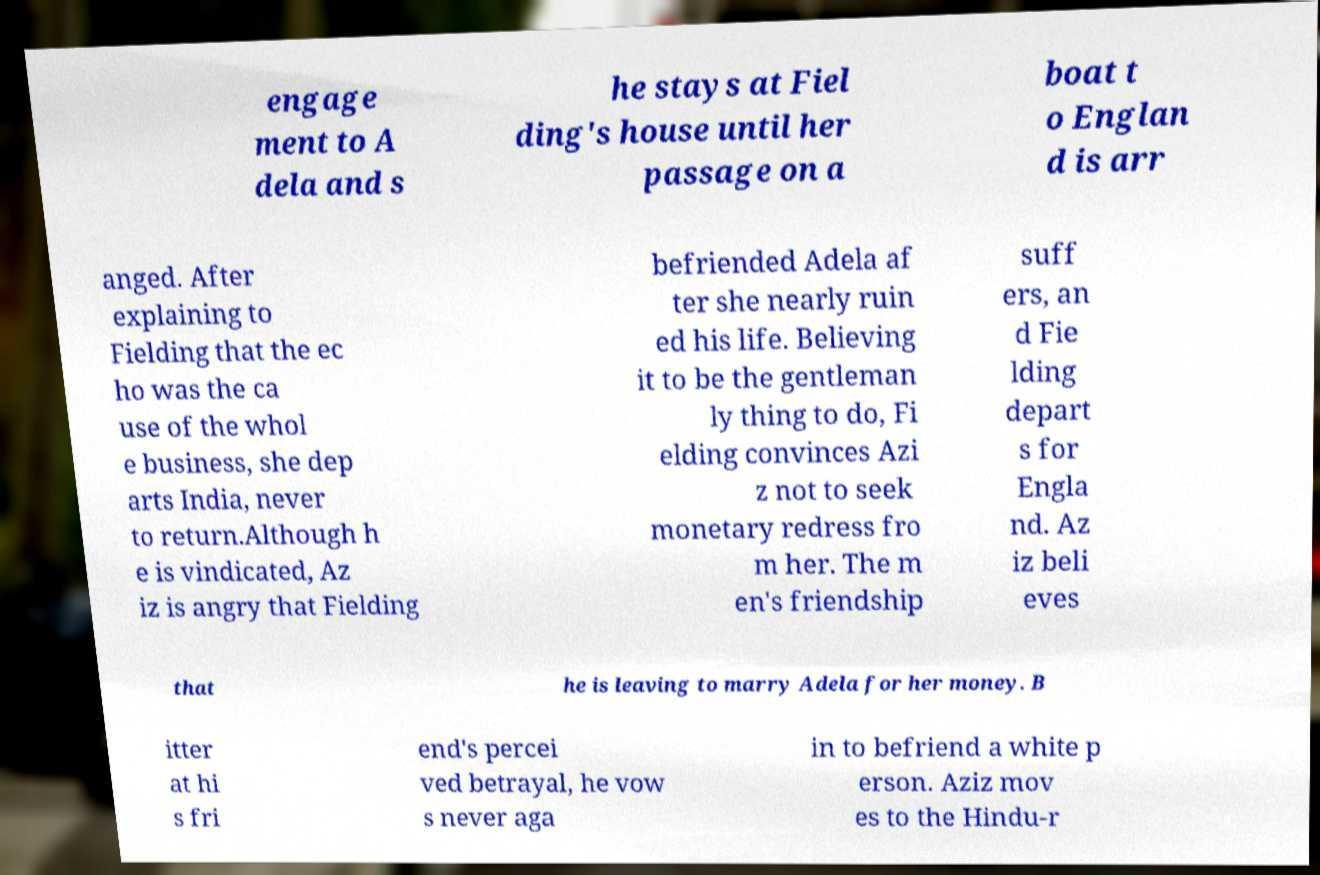For documentation purposes, I need the text within this image transcribed. Could you provide that? engage ment to A dela and s he stays at Fiel ding's house until her passage on a boat t o Englan d is arr anged. After explaining to Fielding that the ec ho was the ca use of the whol e business, she dep arts India, never to return.Although h e is vindicated, Az iz is angry that Fielding befriended Adela af ter she nearly ruin ed his life. Believing it to be the gentleman ly thing to do, Fi elding convinces Azi z not to seek monetary redress fro m her. The m en's friendship suff ers, an d Fie lding depart s for Engla nd. Az iz beli eves that he is leaving to marry Adela for her money. B itter at hi s fri end's percei ved betrayal, he vow s never aga in to befriend a white p erson. Aziz mov es to the Hindu-r 